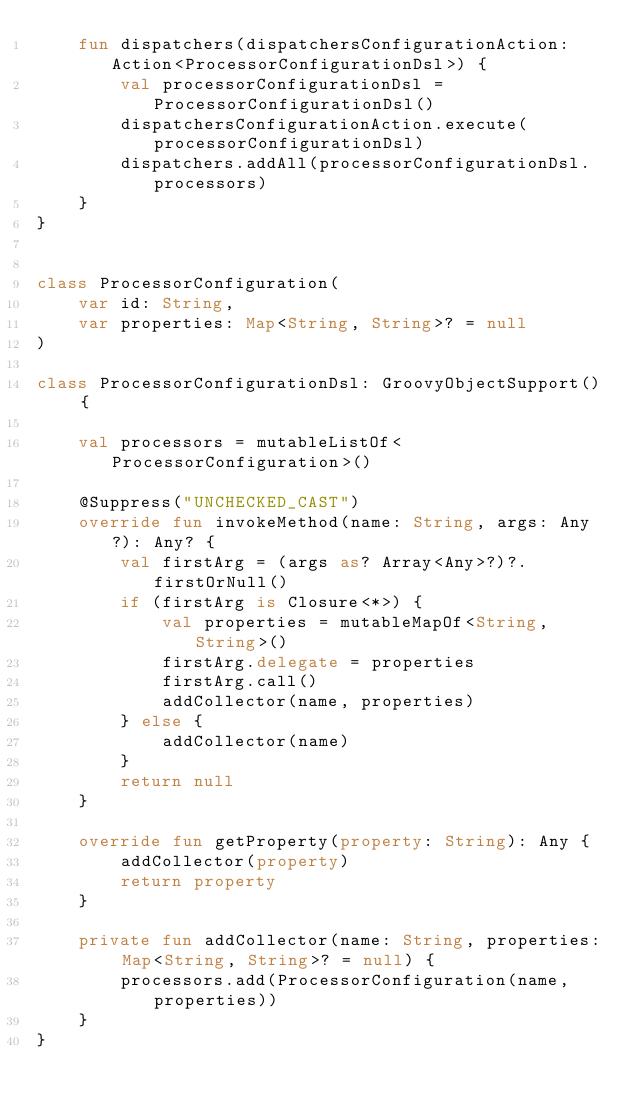<code> <loc_0><loc_0><loc_500><loc_500><_Kotlin_>    fun dispatchers(dispatchersConfigurationAction: Action<ProcessorConfigurationDsl>) {
        val processorConfigurationDsl = ProcessorConfigurationDsl()
        dispatchersConfigurationAction.execute(processorConfigurationDsl)
        dispatchers.addAll(processorConfigurationDsl.processors)
    }
}


class ProcessorConfiguration(
    var id: String,
    var properties: Map<String, String>? = null
)

class ProcessorConfigurationDsl: GroovyObjectSupport() {

    val processors = mutableListOf<ProcessorConfiguration>()

    @Suppress("UNCHECKED_CAST")
    override fun invokeMethod(name: String, args: Any?): Any? {
        val firstArg = (args as? Array<Any>?)?.firstOrNull()
        if (firstArg is Closure<*>) {
            val properties = mutableMapOf<String, String>()
            firstArg.delegate = properties
            firstArg.call()
            addCollector(name, properties)
        } else {
            addCollector(name)
        }
        return null
    }

    override fun getProperty(property: String): Any {
        addCollector(property)
        return property
    }

    private fun addCollector(name: String, properties: Map<String, String>? = null) {
        processors.add(ProcessorConfiguration(name, properties))
    }
}</code> 